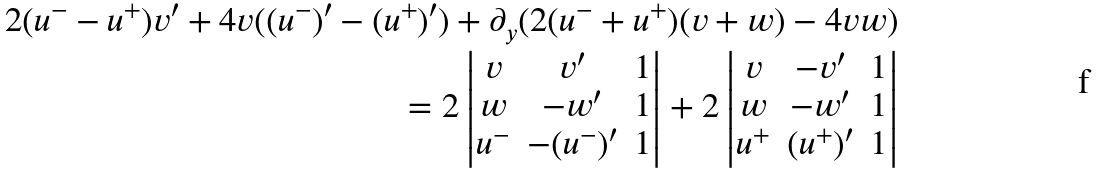<formula> <loc_0><loc_0><loc_500><loc_500>2 ( u ^ { - } - u ^ { + } ) v ^ { \prime } + 4 v ( ( u ^ { - } ) ^ { \prime } - ( u ^ { + } ) ^ { \prime } ) + \partial _ { y } ( 2 ( u ^ { - } + u ^ { + } ) ( v + w ) - 4 v w ) \\ \quad = 2 \left | \begin{matrix} v & v ^ { \prime } & 1 \\ w & - w ^ { \prime } & 1 \\ u ^ { - } & - ( u ^ { - } ) ^ { \prime } & 1 \end{matrix} \right | + 2 \left | \begin{matrix} v & - v ^ { \prime } & 1 \\ w & - w ^ { \prime } & 1 \\ u ^ { + } & ( u ^ { + } ) ^ { \prime } & 1 \end{matrix} \right |</formula> 